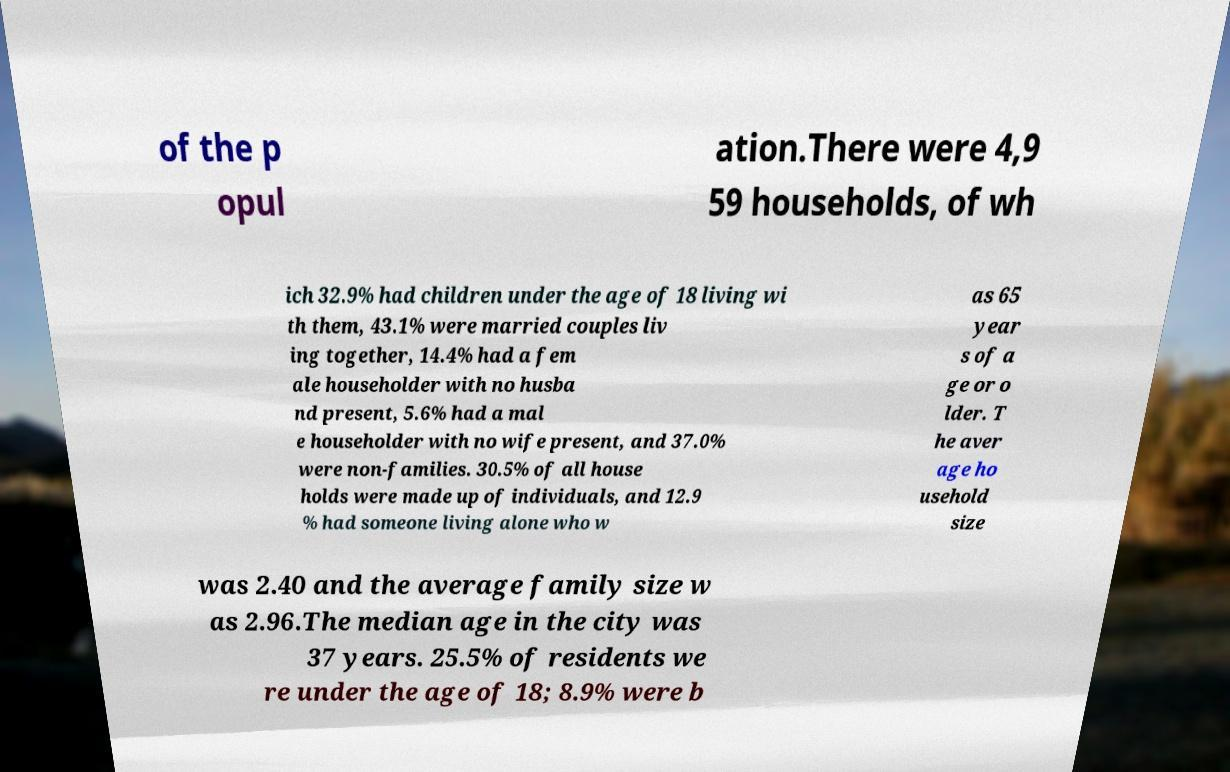Could you extract and type out the text from this image? of the p opul ation.There were 4,9 59 households, of wh ich 32.9% had children under the age of 18 living wi th them, 43.1% were married couples liv ing together, 14.4% had a fem ale householder with no husba nd present, 5.6% had a mal e householder with no wife present, and 37.0% were non-families. 30.5% of all house holds were made up of individuals, and 12.9 % had someone living alone who w as 65 year s of a ge or o lder. T he aver age ho usehold size was 2.40 and the average family size w as 2.96.The median age in the city was 37 years. 25.5% of residents we re under the age of 18; 8.9% were b 